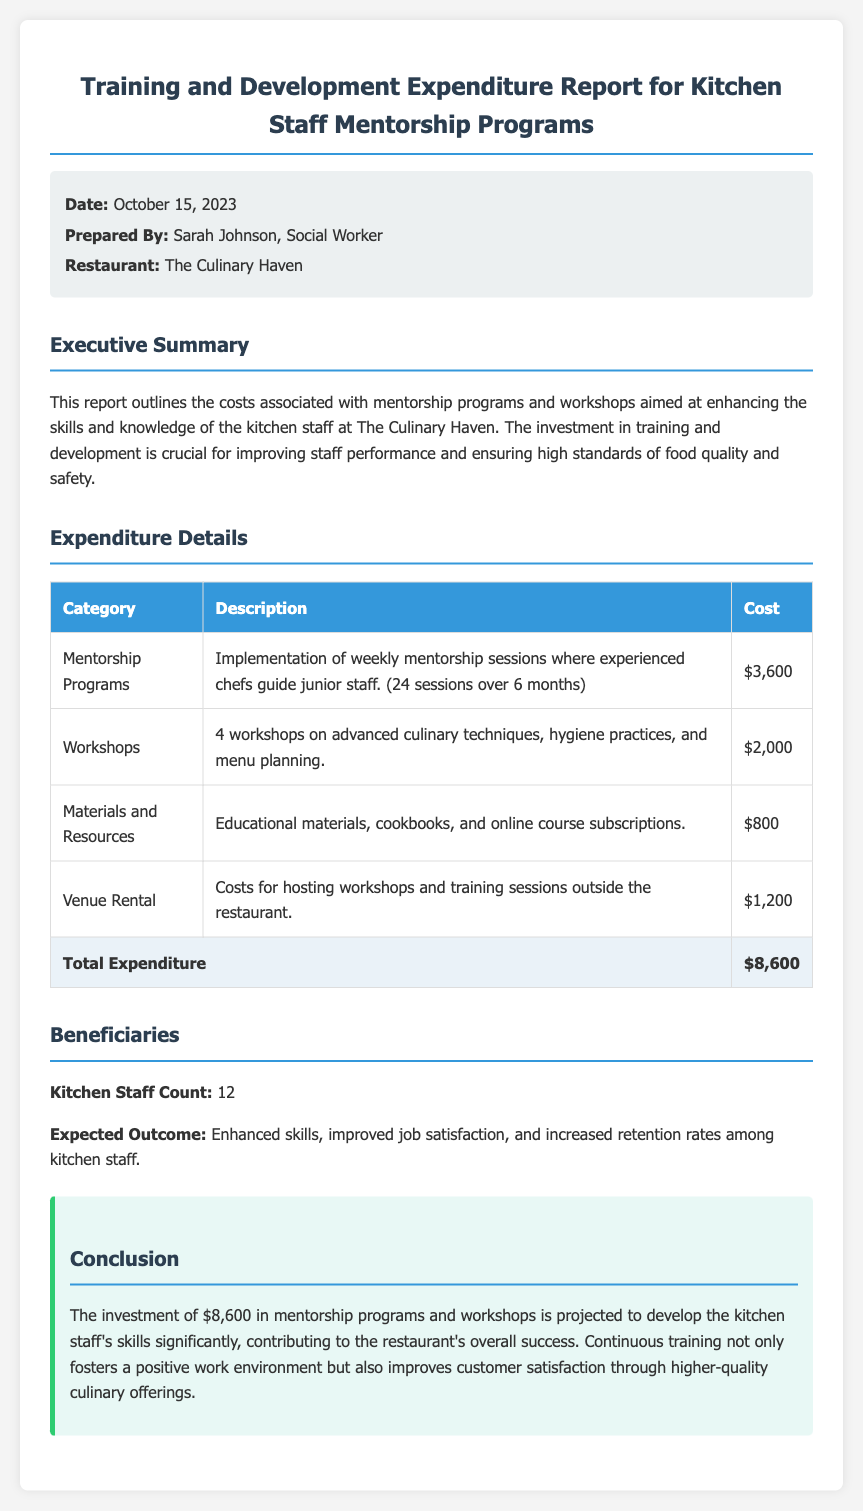what is the date of the report? The report is dated October 15, 2023, as mentioned in the meta-info section.
Answer: October 15, 2023 who prepared the report? The report was prepared by Sarah Johnson, which is specified in the meta-info section.
Answer: Sarah Johnson how much is allocated for mentorship programs? The cost for mentorship programs is stated to be $3,600 in the expenditure details.
Answer: $3,600 what is the total expenditure reported? The total expenditure is summarized in the table, noting that the total is $8,600.
Answer: $8,600 how many workshops were conducted? The report indicates that there were 4 workshops on various topics.
Answer: 4 what is the expected outcome for the kitchen staff? The expected outcome outlined is enhanced skills, improved job satisfaction, and increased retention rates among staff.
Answer: Enhanced skills, improved job satisfaction, and increased retention rates what count of kitchen staff benefited from the training? The report mentions that the count of kitchen staff is 12.
Answer: 12 what cost is associated with venue rental? The document specifies that the venue rental cost is $1,200 in the expenditure details.
Answer: $1,200 what category includes educational materials? Educational materials fall under the "Materials and Resources" category in the expenditure table.
Answer: Materials and Resources 